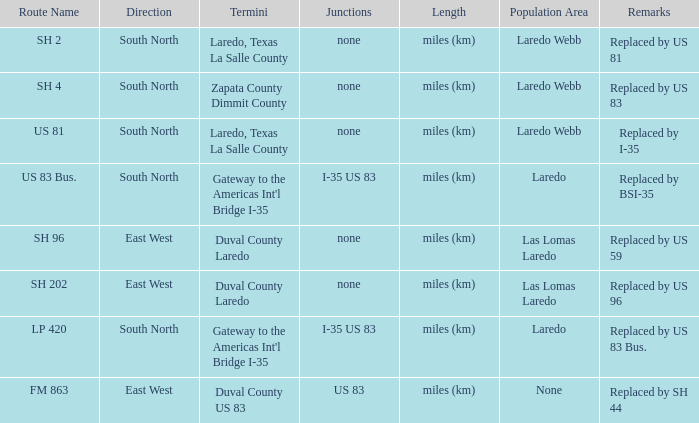How many junctions feature "replaced by bsi-35" in their remarks section? 1.0. 